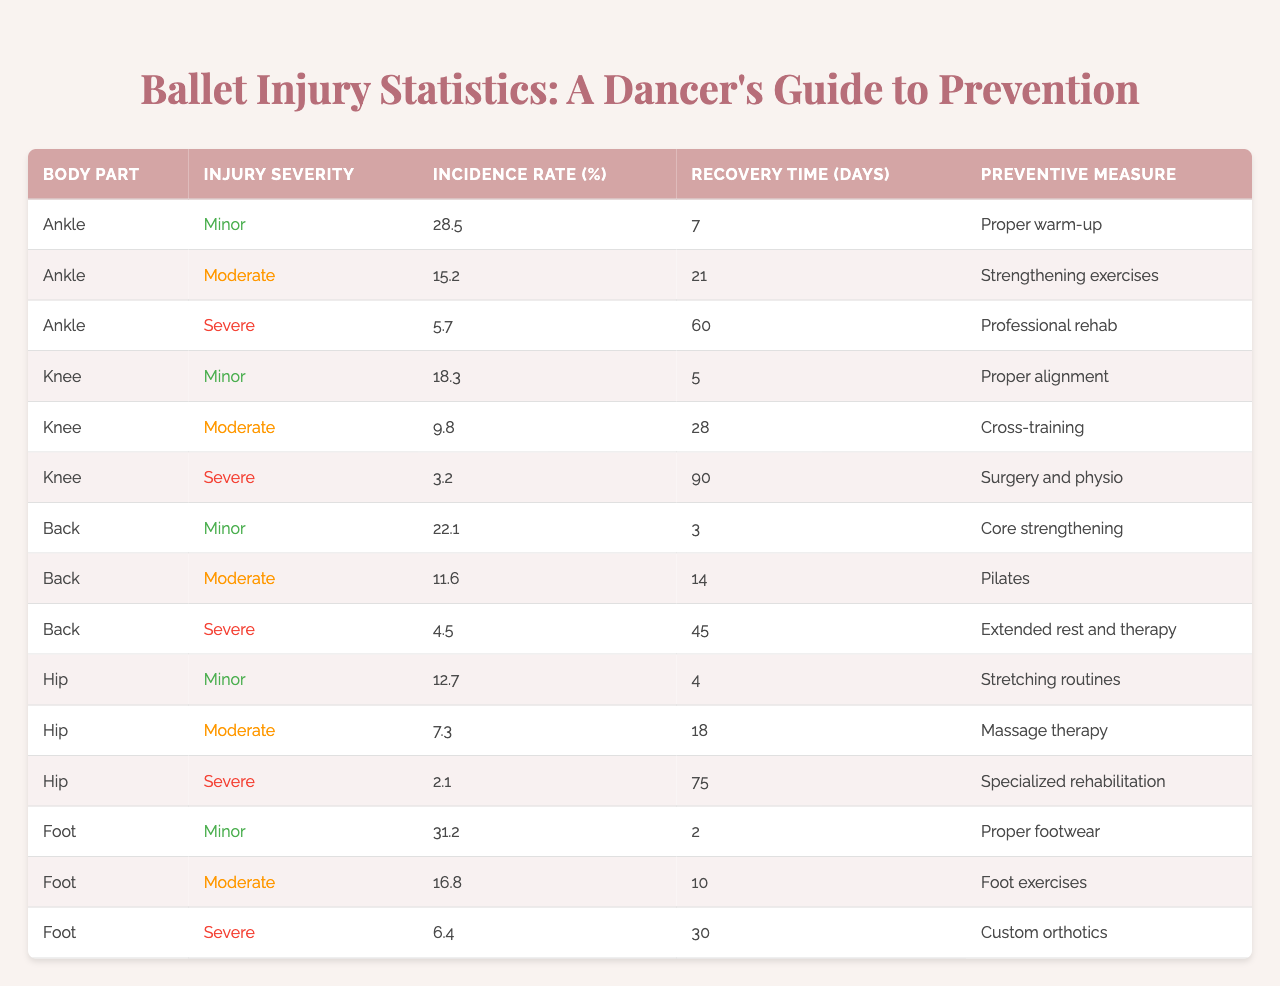What is the incidence rate of severe ankle injuries? The table shows that the incidence rate of severe ankle injuries is 5.7%.
Answer: 5.7% Which body part has the highest incidence rate of minor injuries? Looking at the table, the foot has the highest incidence rate of minor injuries at 31.2%.
Answer: 31.2% What is the recovery time for moderate knee injuries? The recovery time for moderate knee injuries is 28 days according to the table.
Answer: 28 days Is the preventive measure for severe hip injuries specialized rehabilitation? Yes, the table indicates that the preventive measure for severe hip injuries is specialized rehabilitation.
Answer: Yes What is the average recovery time for minor injuries across all body parts? Adding the recovery times for minor injuries: (7 + 5 + 3 + 4 + 2) = 21 days and dividing by the 5 instances gives an average recovery time of 21/5 = 4.2 days.
Answer: 4.2 days How many days does it take to recover from severe knee injuries? The table states that it takes 90 days to recover from severe knee injuries.
Answer: 90 days What is the incidence rate of minor injuries for the back? The incidence rate of minor injuries for the back is 22.1%.
Answer: 22.1% Which preventive measure is recommended for moderate ankle injuries? The recommended preventive measure for moderate ankle injuries is strengthening exercises according to the table.
Answer: Strengthening exercises What is the difference in recovery time between severe ankle and severe knee injuries? Severe ankle injuries require 60 days of recovery, while severe knee injuries require 90 days. The difference is 90 - 60 = 30 days.
Answer: 30 days Which body part has the lowest incidence rate for severe injuries? The hip has the lowest incidence rate for severe injuries at 2.1%.
Answer: 2.1% 